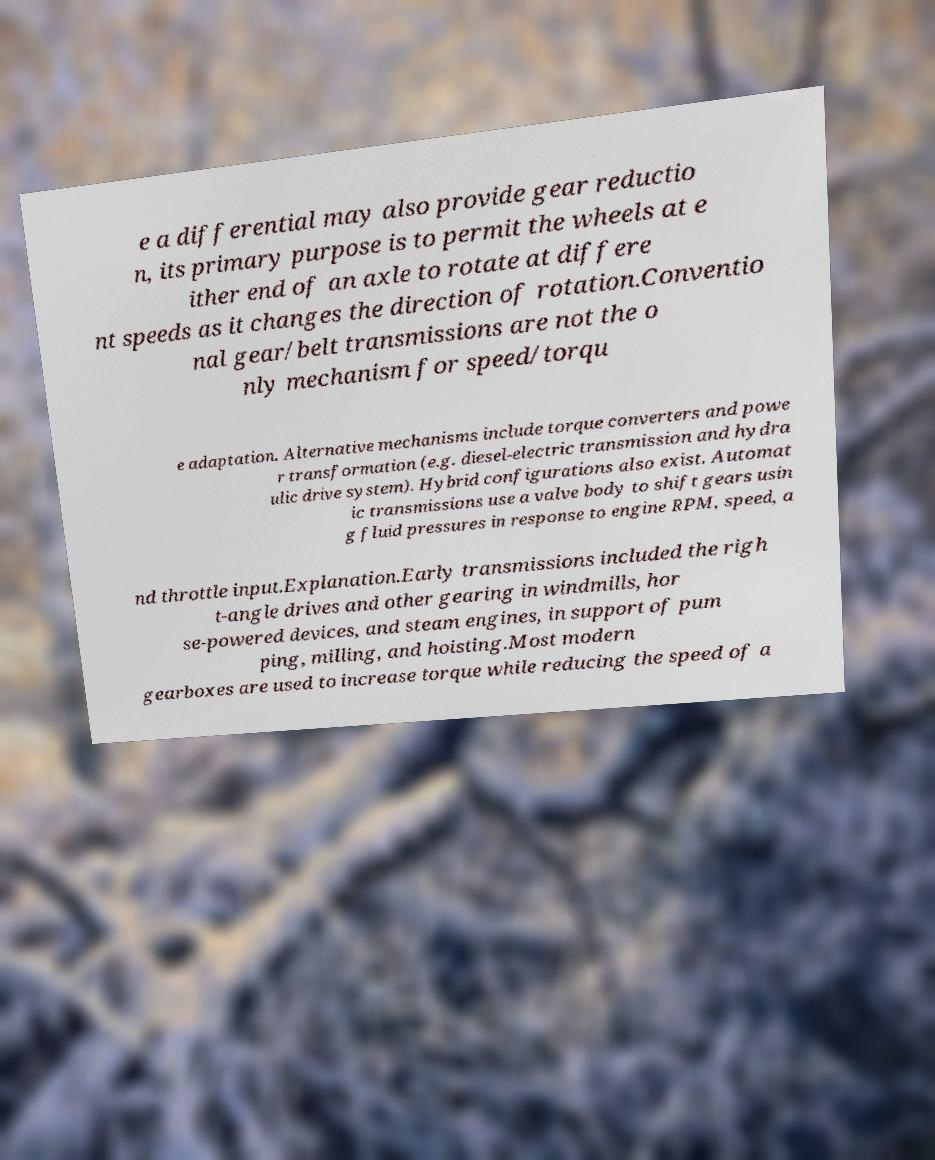For documentation purposes, I need the text within this image transcribed. Could you provide that? e a differential may also provide gear reductio n, its primary purpose is to permit the wheels at e ither end of an axle to rotate at differe nt speeds as it changes the direction of rotation.Conventio nal gear/belt transmissions are not the o nly mechanism for speed/torqu e adaptation. Alternative mechanisms include torque converters and powe r transformation (e.g. diesel-electric transmission and hydra ulic drive system). Hybrid configurations also exist. Automat ic transmissions use a valve body to shift gears usin g fluid pressures in response to engine RPM, speed, a nd throttle input.Explanation.Early transmissions included the righ t-angle drives and other gearing in windmills, hor se-powered devices, and steam engines, in support of pum ping, milling, and hoisting.Most modern gearboxes are used to increase torque while reducing the speed of a 